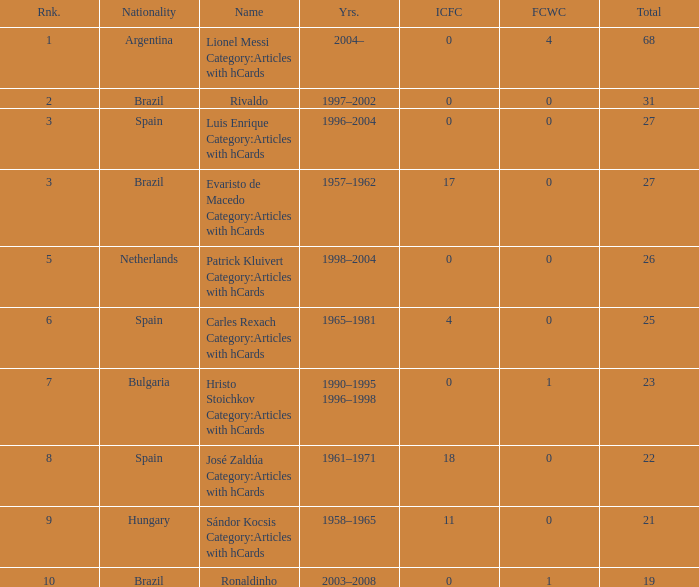What is the highest number of FCWC in the Years of 1958–1965, and an ICFC smaller than 11? None. 